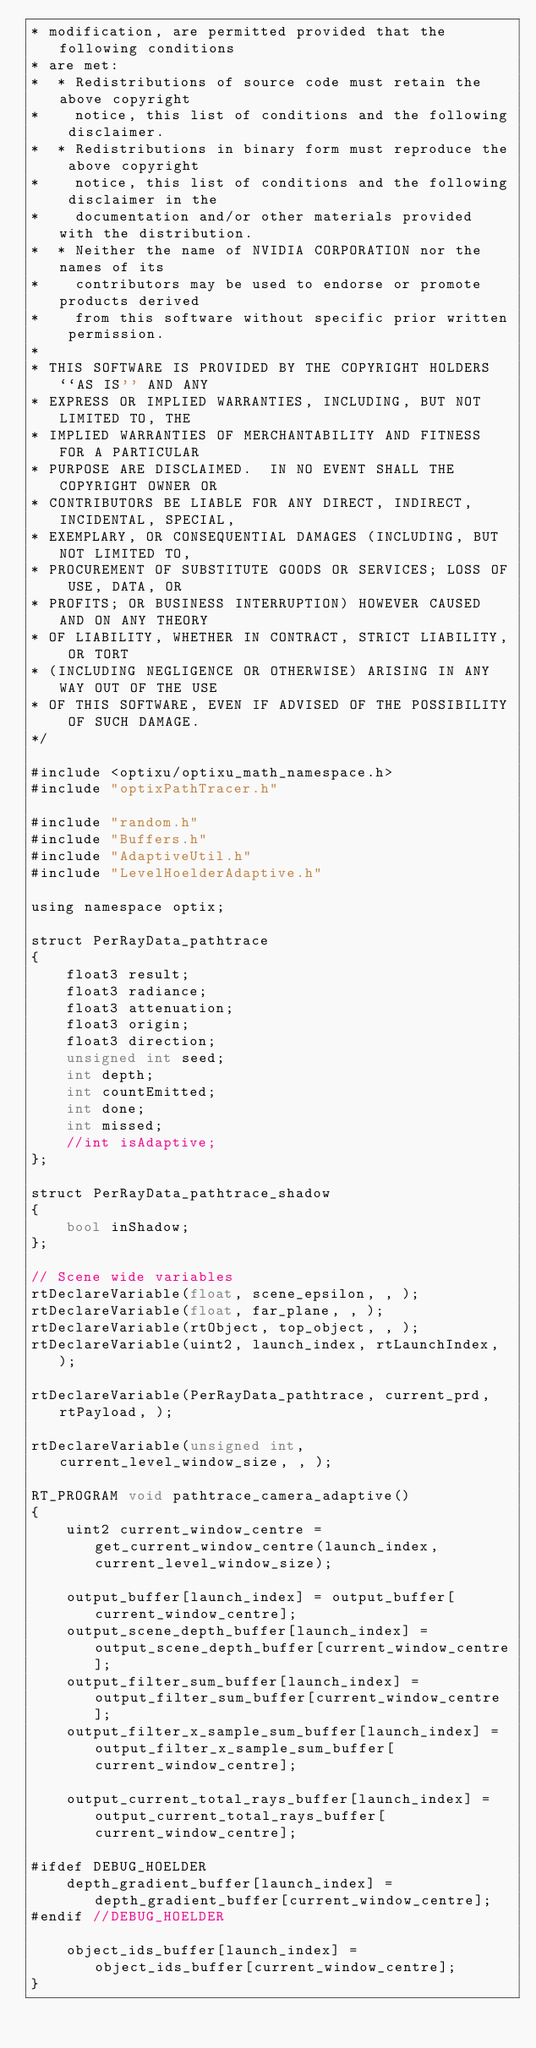<code> <loc_0><loc_0><loc_500><loc_500><_Cuda_>* modification, are permitted provided that the following conditions
* are met:
*  * Redistributions of source code must retain the above copyright
*    notice, this list of conditions and the following disclaimer.
*  * Redistributions in binary form must reproduce the above copyright
*    notice, this list of conditions and the following disclaimer in the
*    documentation and/or other materials provided with the distribution.
*  * Neither the name of NVIDIA CORPORATION nor the names of its
*    contributors may be used to endorse or promote products derived
*    from this software without specific prior written permission.
*
* THIS SOFTWARE IS PROVIDED BY THE COPYRIGHT HOLDERS ``AS IS'' AND ANY
* EXPRESS OR IMPLIED WARRANTIES, INCLUDING, BUT NOT LIMITED TO, THE
* IMPLIED WARRANTIES OF MERCHANTABILITY AND FITNESS FOR A PARTICULAR
* PURPOSE ARE DISCLAIMED.  IN NO EVENT SHALL THE COPYRIGHT OWNER OR
* CONTRIBUTORS BE LIABLE FOR ANY DIRECT, INDIRECT, INCIDENTAL, SPECIAL,
* EXEMPLARY, OR CONSEQUENTIAL DAMAGES (INCLUDING, BUT NOT LIMITED TO,
* PROCUREMENT OF SUBSTITUTE GOODS OR SERVICES; LOSS OF USE, DATA, OR
* PROFITS; OR BUSINESS INTERRUPTION) HOWEVER CAUSED AND ON ANY THEORY
* OF LIABILITY, WHETHER IN CONTRACT, STRICT LIABILITY, OR TORT
* (INCLUDING NEGLIGENCE OR OTHERWISE) ARISING IN ANY WAY OUT OF THE USE
* OF THIS SOFTWARE, EVEN IF ADVISED OF THE POSSIBILITY OF SUCH DAMAGE.
*/

#include <optixu/optixu_math_namespace.h>
#include "optixPathTracer.h"

#include "random.h"
#include "Buffers.h"
#include "AdaptiveUtil.h"
#include "LevelHoelderAdaptive.h"

using namespace optix;

struct PerRayData_pathtrace
{
	float3 result;
	float3 radiance;
	float3 attenuation;
	float3 origin;
	float3 direction;
	unsigned int seed;
	int depth;
	int countEmitted;
	int done;
	int missed;
	//int isAdaptive;
};

struct PerRayData_pathtrace_shadow
{
	bool inShadow;
};

// Scene wide variables
rtDeclareVariable(float, scene_epsilon, , );
rtDeclareVariable(float, far_plane, , );
rtDeclareVariable(rtObject, top_object, , );
rtDeclareVariable(uint2, launch_index, rtLaunchIndex, );

rtDeclareVariable(PerRayData_pathtrace, current_prd, rtPayload, );

rtDeclareVariable(unsigned int, current_level_window_size, , );

RT_PROGRAM void pathtrace_camera_adaptive()
{
	uint2 current_window_centre = get_current_window_centre(launch_index, current_level_window_size);

	output_buffer[launch_index] = output_buffer[current_window_centre];
	output_scene_depth_buffer[launch_index] = output_scene_depth_buffer[current_window_centre];
	output_filter_sum_buffer[launch_index] = output_filter_sum_buffer[current_window_centre];
	output_filter_x_sample_sum_buffer[launch_index] = output_filter_x_sample_sum_buffer[current_window_centre];

	output_current_total_rays_buffer[launch_index] = output_current_total_rays_buffer[current_window_centre];

#ifdef DEBUG_HOELDER
	depth_gradient_buffer[launch_index] = depth_gradient_buffer[current_window_centre];
#endif //DEBUG_HOELDER

	object_ids_buffer[launch_index] = object_ids_buffer[current_window_centre];
}
</code> 